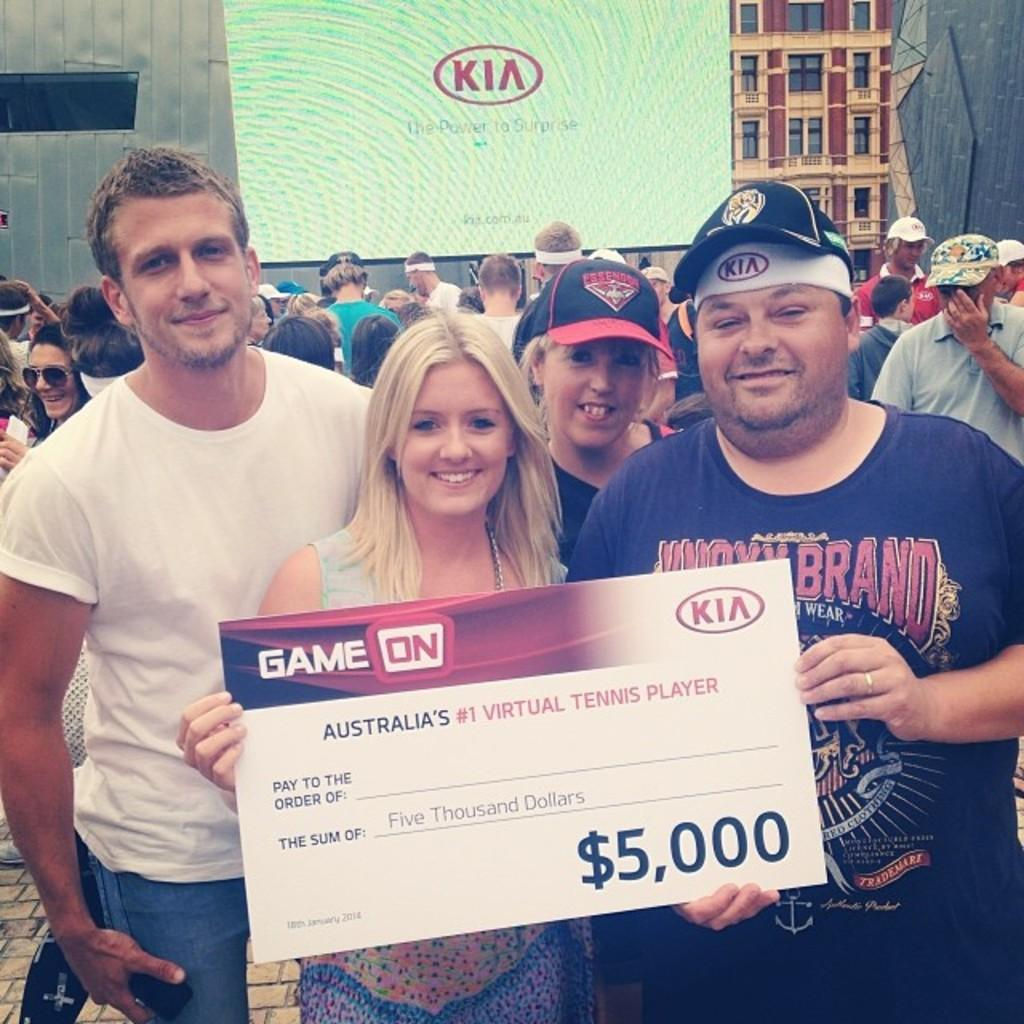What type of structures can be seen in the image? There are buildings in the image. Are there any people present in the image? Yes, there is a group of people in the image. What else can be seen in the image besides the buildings and people? There is a banner in the image. How does the man in the image increase his approval rating? There is no man present in the image, so it is not possible to determine how his approval rating might be increased. 